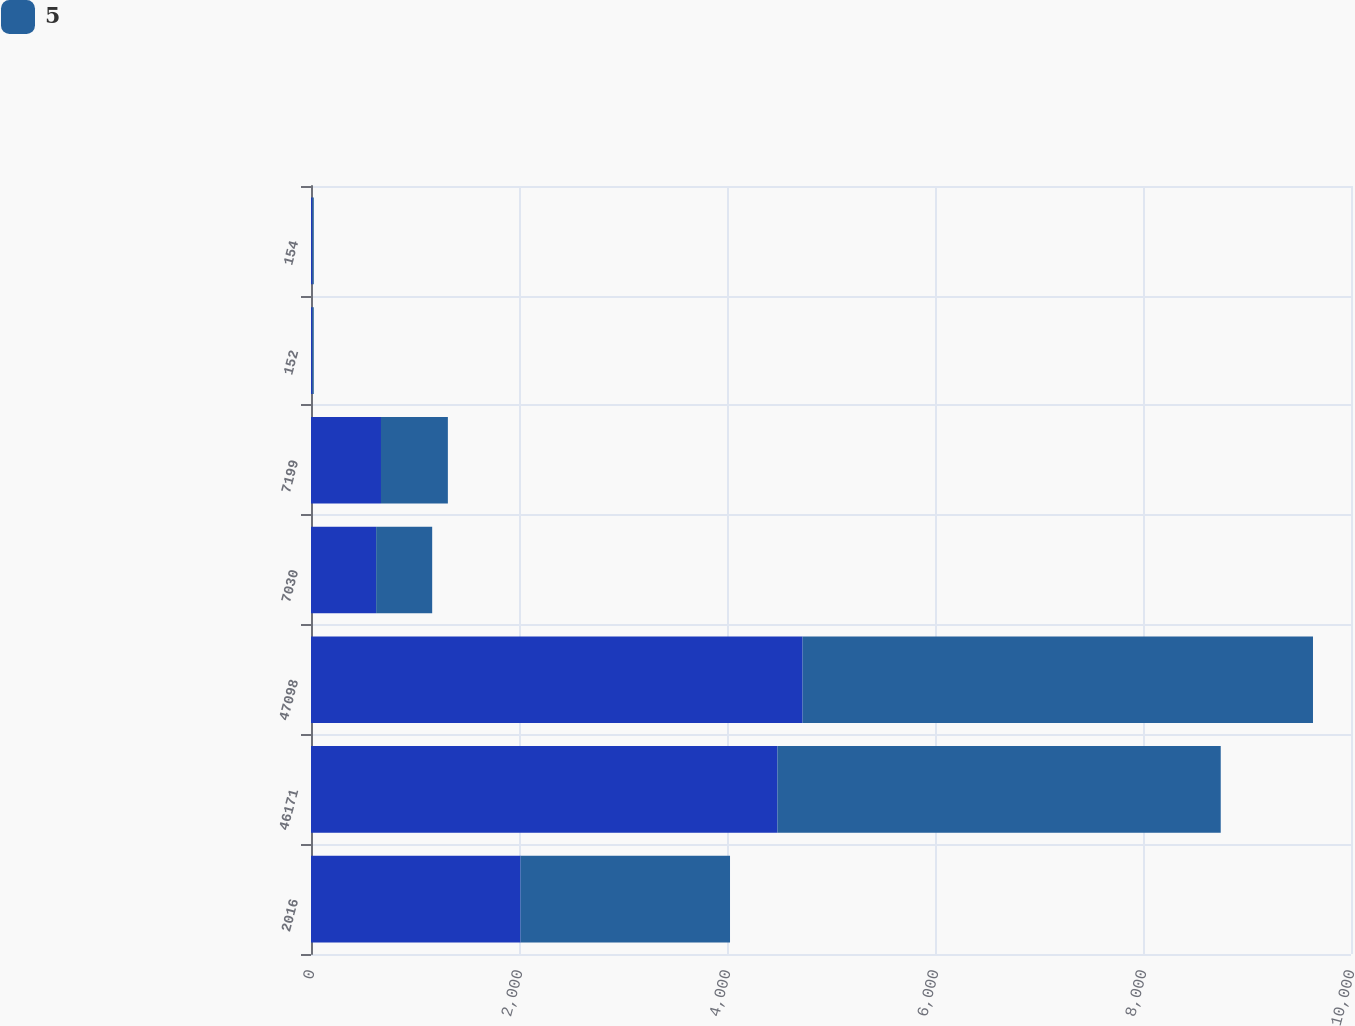Convert chart to OTSL. <chart><loc_0><loc_0><loc_500><loc_500><stacked_bar_chart><ecel><fcel>2016<fcel>46171<fcel>47098<fcel>7030<fcel>7199<fcel>152<fcel>154<nl><fcel>nan<fcel>2015<fcel>4485.5<fcel>4726.9<fcel>626.4<fcel>673<fcel>14<fcel>14.1<nl><fcel>5<fcel>2014<fcel>4261.9<fcel>4907.6<fcel>538.8<fcel>643.1<fcel>12.6<fcel>12.8<nl></chart> 